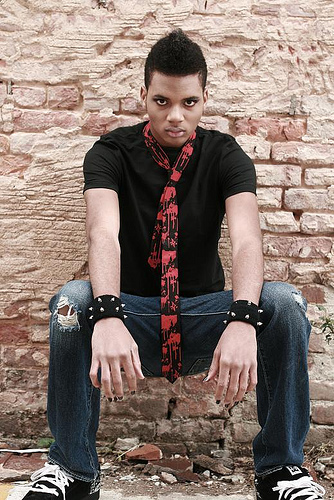What emotions might the person in the image be feeling? Judging by his body language and facial expression, he seems to be feeling introspective or serious. His gaze is direct and there is a slight frown, which could indicate a contemplative or determined state of mind. 